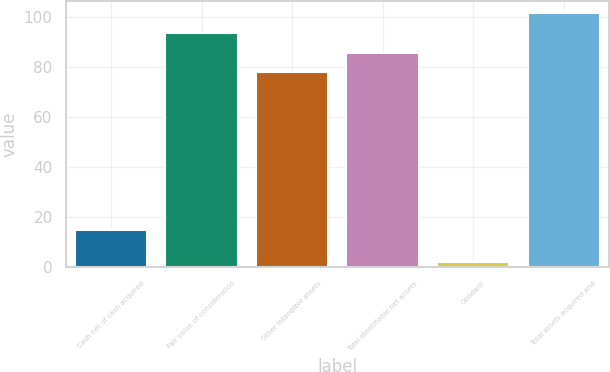<chart> <loc_0><loc_0><loc_500><loc_500><bar_chart><fcel>Cash net of cash acquired<fcel>Fair value of consideration<fcel>Other intangible assets<fcel>Total identifiable net assets<fcel>Goodwill<fcel>Total assets acquired and<nl><fcel>15<fcel>93.6<fcel>78<fcel>85.8<fcel>2<fcel>101.4<nl></chart> 